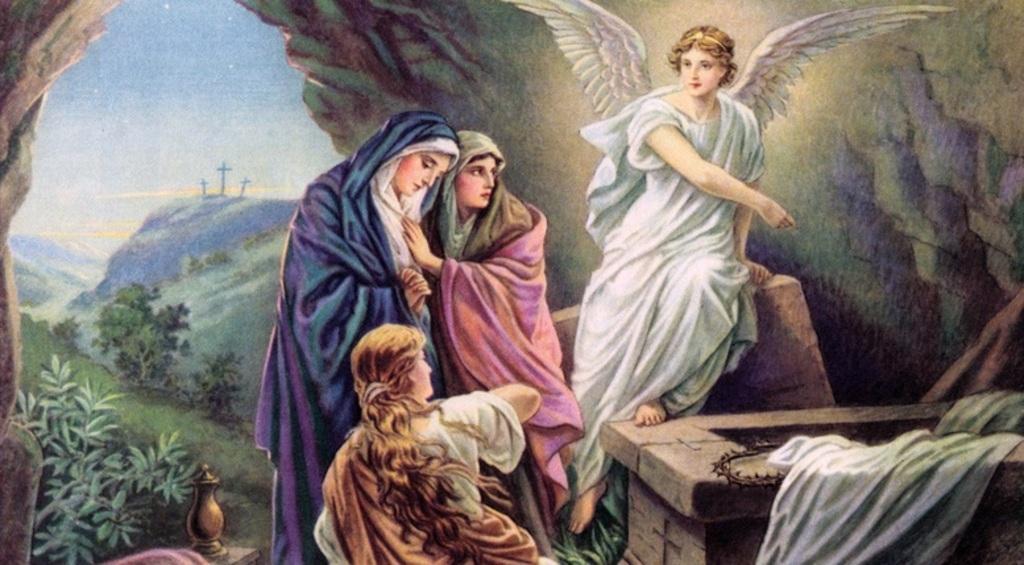Can you describe this image briefly? In this picture I can see a poster and I can see few people and trees and I can see poles and a cloudy sky. 